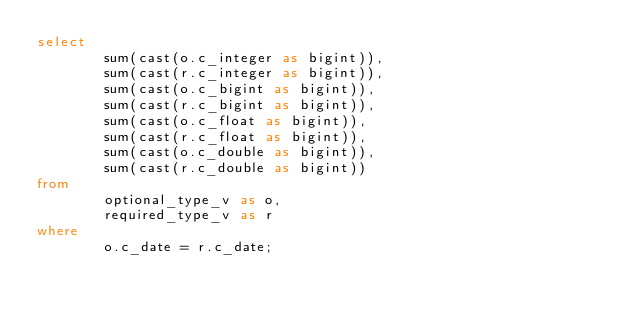Convert code to text. <code><loc_0><loc_0><loc_500><loc_500><_SQL_>select 
        sum(cast(o.c_integer as bigint)),
        sum(cast(r.c_integer as bigint)),
        sum(cast(o.c_bigint as bigint)),
        sum(cast(r.c_bigint as bigint)), 
        sum(cast(o.c_float as bigint)),
        sum(cast(r.c_float as bigint)), 
        sum(cast(o.c_double as bigint)),
        sum(cast(r.c_double as bigint))
from 
        optional_type_v as o,
        required_type_v as r
where
        o.c_date = r.c_date;
</code> 